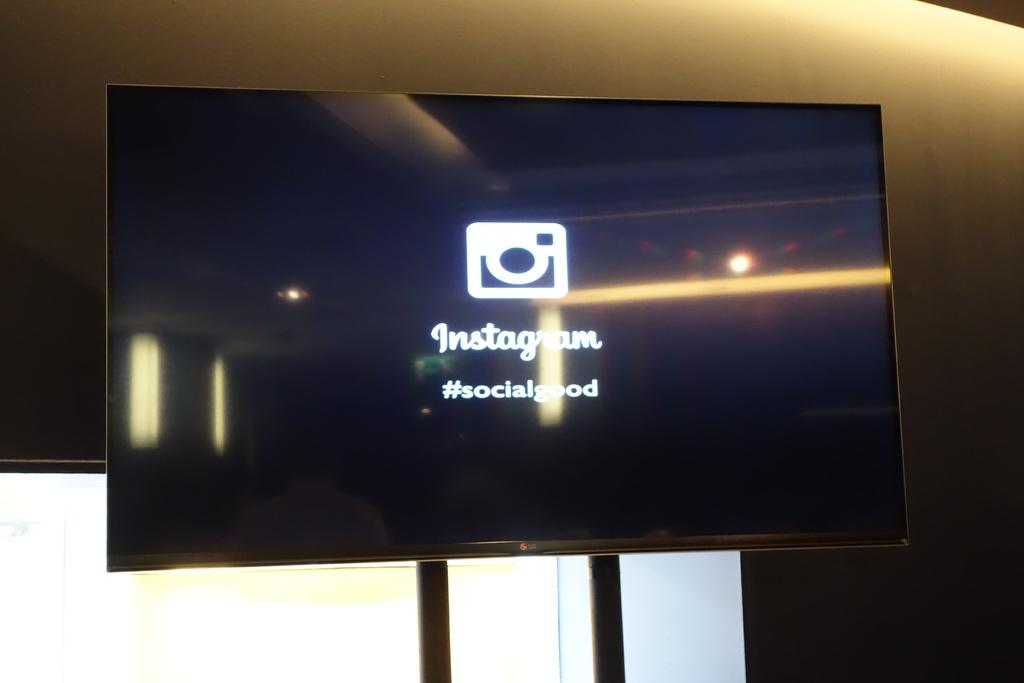Provide a one-sentence caption for the provided image. a monitor with Instagram logo and #socialgood on it. 